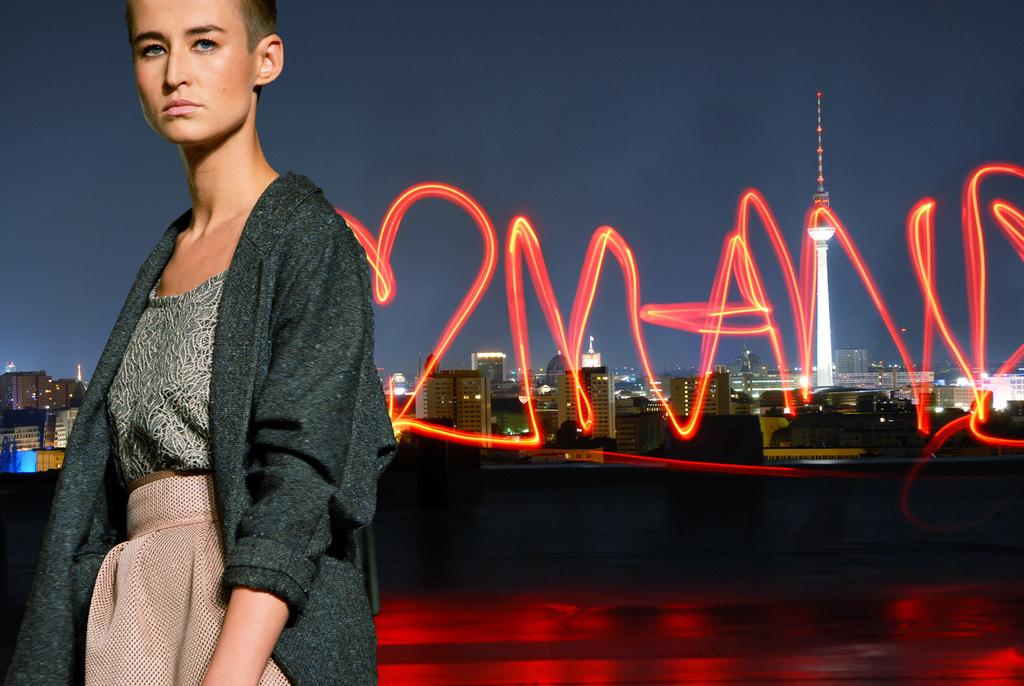What is the main subject of the image? There is a lady standing in the image. What can be seen in the background of the image? There are buildings, a tower, some text, and the sky visible in the background of the image. What type of straw is the lady holding in the image? There is no straw present in the image. What kind of boot is visible on the tower in the image? There is no boot visible on the tower in the image. 